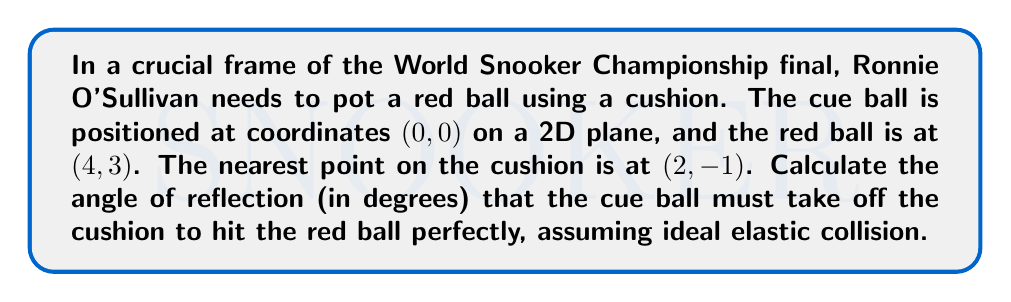Teach me how to tackle this problem. Let's approach this step-by-step:

1) First, we need to understand that the angle of incidence equals the angle of reflection. This is key to solving the problem.

2) Let's visualize the situation:

[asy]
unitsize(1cm);
pair O=(0,0), C=(2,-1), R=(4,3);
draw(O--C--R,blue);
draw((-1,-2)--(5,-2),black);
dot(O); dot(C); dot(R);
label("Cue ball (0,0)",O,NW);
label("Cushion point (2,-1)",C,S);
label("Red ball (4,3)",R,NE);
label("Cushion",(-1,-2),SW);
[/asy]

3) We need to find two angles:
   a) The angle of incidence (and reflection) at the cushion point
   b) The angle between the cushion and the line from cushion to red ball

4) To find these angles, we'll use the arctangent function. But first, we need the slopes of our lines.

5) For the line from cue ball to cushion:
   $m_1 = \frac{-1-0}{2-0} = -\frac{1}{2}$

6) For the line from cushion to red ball:
   $m_2 = \frac{3-(-1)}{4-2} = 2$

7) The angle of incidence (and reflection) is:
   $\theta_1 = \arctan|-\frac{1}{2}| = \arctan(0.5)$

8) The angle between the cushion and line to red ball is:
   $\theta_2 = \arctan|2| = \arctan(2)$

9) The total angle we're looking for is the sum of these two angles:
   $\theta_{total} = \theta_1 + \theta_2 = \arctan(0.5) + \arctan(2)$

10) Converting to degrees:
    $\theta_{total} = (\arctan(0.5) + \arctan(2)) * \frac{180}{\pi}$
Answer: $$\theta_{total} = (\arctan(0.5) + \arctan(2)) * \frac{180}{\pi} \approx 78.69°$$ 